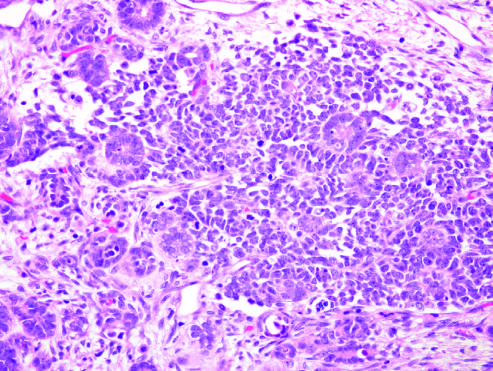s wilms tumor with tightly packed blue cells consistented with the blastemal component and intersperse primitive tubules, representing the epithelial component?
Answer the question using a single word or phrase. Yes 